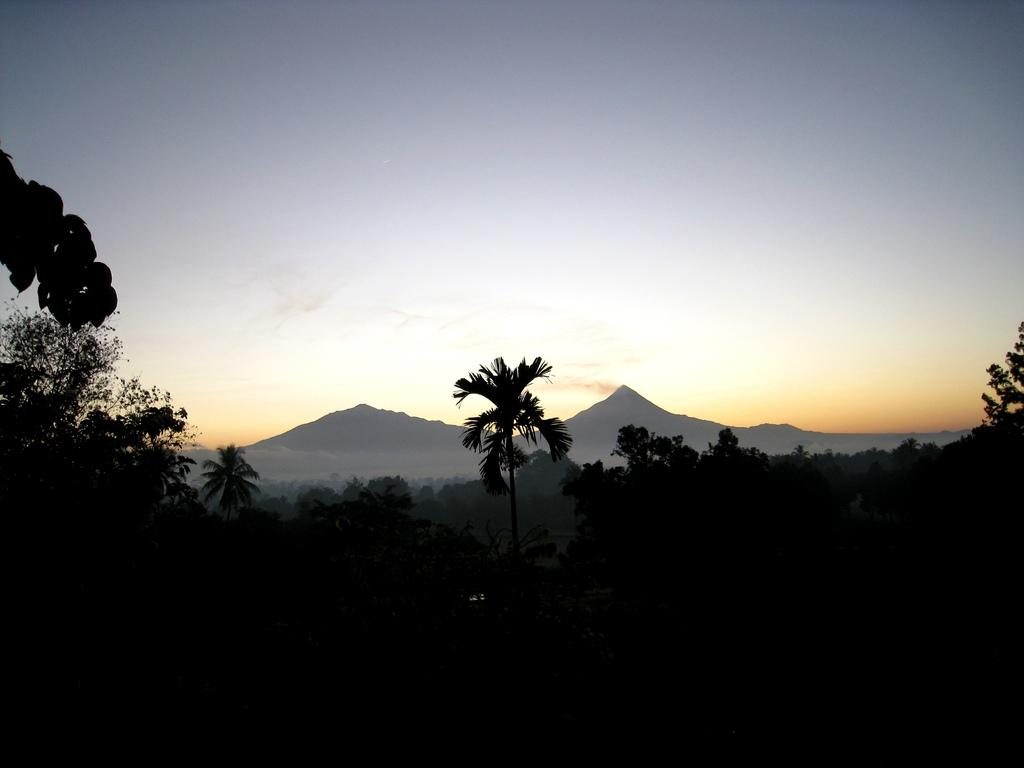What type of vegetation can be seen in the image? There are trees in the image. What can be seen in the distance in the image? There are hills in the background of the image. What is visible at the top of the image? The sky is visible at the top of the image. What is the color of the bottom part of the image? The bottom part of the image is black in color. Can you tell me how many oranges are on the trees in the image? There are no oranges present in the image; it features trees without any visible fruits. What type of mark can be seen on the trees in the image? There are no marks visible on the trees in the image. 